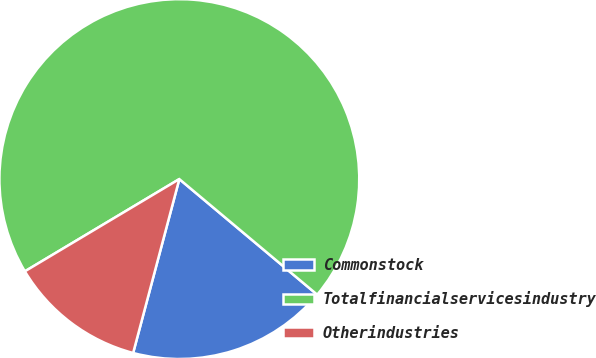Convert chart. <chart><loc_0><loc_0><loc_500><loc_500><pie_chart><fcel>Commonstock<fcel>Totalfinancialservicesindustry<fcel>Otherindustries<nl><fcel>18.03%<fcel>69.67%<fcel>12.3%<nl></chart> 